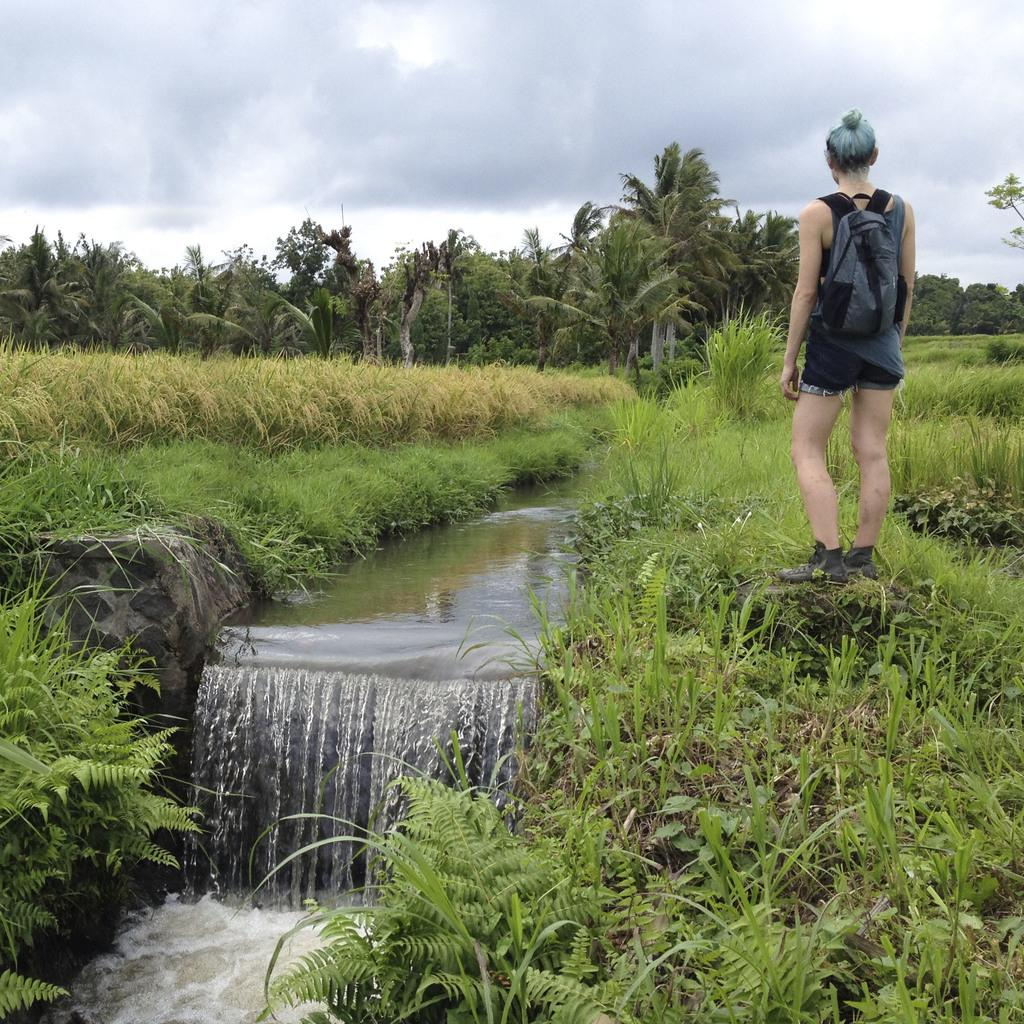What is happening in the image involving water? There is a water flow in the image. What is the surrounding environment of the water flow? The water flow is between grass fields. Can you describe any people present in the image? There is a person wearing a backpack in the image. What type of vegetation can be seen in the image? There are trees visible in the image. What type of clam can be seen in the image? There are no clams present in the image; it features a water flow between grass fields. How does the person fold their backpack in the image? The image does not show the person folding their backpack; they are simply wearing it. 